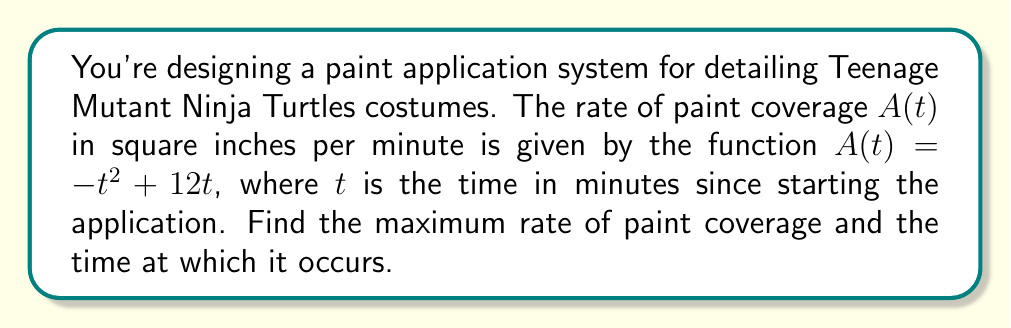Provide a solution to this math problem. 1) To find the maximum rate of paint coverage, we need to find the maximum value of the function $A(t) = -t^2 + 12t$.

2) The maximum of a function occurs where its derivative is zero. Let's find the derivative of $A(t)$:

   $$A'(t) = -2t + 12$$

3) Set the derivative equal to zero and solve for $t$:

   $$-2t + 12 = 0$$
   $$-2t = -12$$
   $$t = 6$$

4) To confirm this is a maximum (not a minimum), check the second derivative:

   $$A''(t) = -2$$

   Since $A''(t)$ is negative, this confirms we have a maximum at $t = 6$.

5) To find the maximum rate, substitute $t = 6$ into the original function:

   $$A(6) = -(6)^2 + 12(6) = -36 + 72 = 36$$

Therefore, the maximum rate of paint coverage is 36 square inches per minute, occurring 6 minutes after starting the application.
Answer: Maximum rate: 36 sq in/min at t = 6 min 